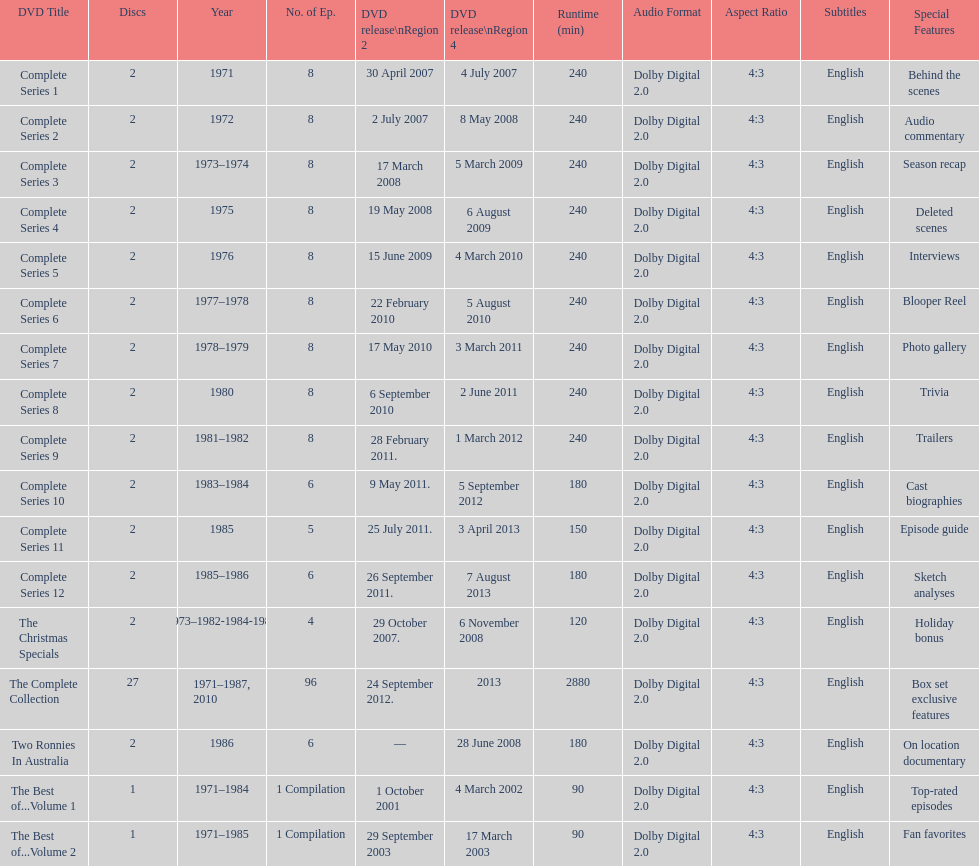How many "best of" volumes compile the top episodes of the television show "the two ronnies". 2. 